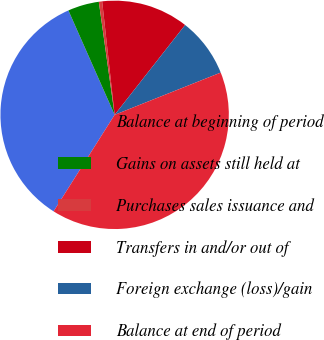Convert chart to OTSL. <chart><loc_0><loc_0><loc_500><loc_500><pie_chart><fcel>Balance at beginning of period<fcel>Gains on assets still held at<fcel>Purchases sales issuance and<fcel>Transfers in and/or out of<fcel>Foreign exchange (loss)/gain<fcel>Balance at end of period<nl><fcel>34.39%<fcel>4.42%<fcel>0.47%<fcel>12.33%<fcel>8.38%<fcel>40.01%<nl></chart> 